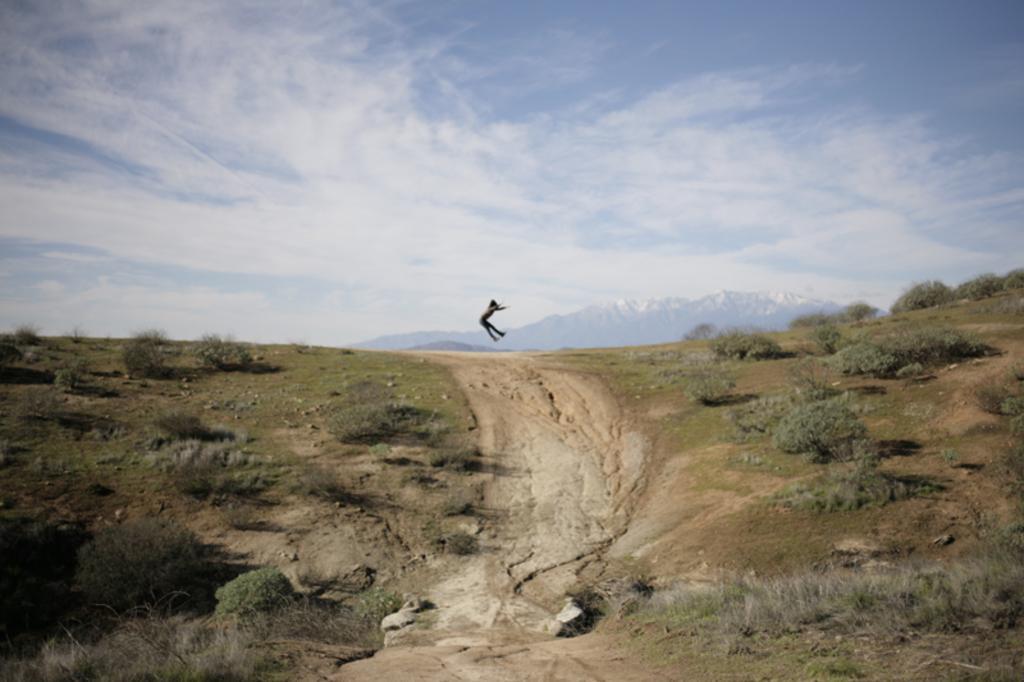Could you give a brief overview of what you see in this image? In the image we can see there is a person jumping in the air and the ground is covered with plants. 